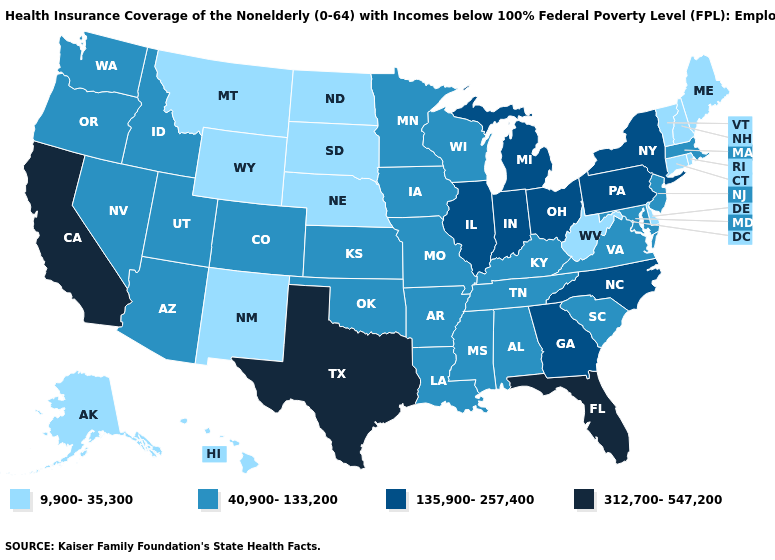Does the first symbol in the legend represent the smallest category?
Quick response, please. Yes. Which states have the lowest value in the Northeast?
Quick response, please. Connecticut, Maine, New Hampshire, Rhode Island, Vermont. Does New Jersey have the highest value in the Northeast?
Keep it brief. No. Name the states that have a value in the range 9,900-35,300?
Write a very short answer. Alaska, Connecticut, Delaware, Hawaii, Maine, Montana, Nebraska, New Hampshire, New Mexico, North Dakota, Rhode Island, South Dakota, Vermont, West Virginia, Wyoming. Is the legend a continuous bar?
Be succinct. No. Among the states that border Rhode Island , which have the highest value?
Answer briefly. Massachusetts. How many symbols are there in the legend?
Write a very short answer. 4. What is the highest value in the USA?
Concise answer only. 312,700-547,200. What is the lowest value in states that border Louisiana?
Answer briefly. 40,900-133,200. What is the lowest value in states that border Tennessee?
Give a very brief answer. 40,900-133,200. What is the value of Ohio?
Answer briefly. 135,900-257,400. Does the first symbol in the legend represent the smallest category?
Answer briefly. Yes. Which states have the highest value in the USA?
Be succinct. California, Florida, Texas. What is the highest value in the USA?
Give a very brief answer. 312,700-547,200. 